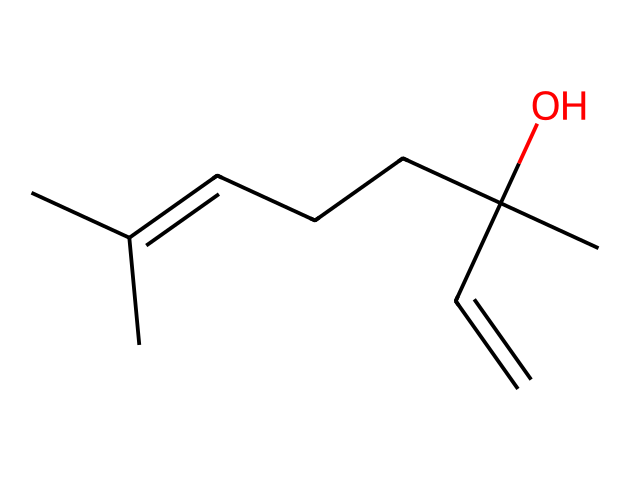What is the molecular formula of linalool? To find the molecular formula, count the number of carbon (C), hydrogen (H), and oxygen (O) atoms in the SMILES representation. The structure has 10 carbons, 18 hydrogens, and 1 oxygen, which gives the molecular formula C10H18O.
Answer: C10H18O How many double bonds are present in the structure? By examining the SMILES, I can identify the double bonds represented in the structure. There are two double bonds in the carbon chain.
Answer: 2 What functional group is present in linalool? Looking at the structure, the presence of an -OH group indicates a hydroxyl functional group. This is crucial as it defines the alcohol classification.
Answer: hydroxyl Is linalool a saturated or unsaturated compound? Since linalool contains double bonds as indicated by the presence of C=C, it is classified as an unsaturated compound because saturation would require all carbon atoms to be bonded by single bonds only.
Answer: unsaturated What type of compound is linalool categorized as? Based on its structure, linalool is a terpene which is characterized by the arrangement of its carbon atoms in a specific framework. Terpenes are derived from plants and often contribute to scents and flavors.
Answer: terpene How many chiral centers are present in linalool? By analyzing the structure, I will check for any carbon atoms that have four different substituents since such carbons are considered chiral centers. The structure shows one carbon atom with four different groups, indicating one chiral center.
Answer: 1 